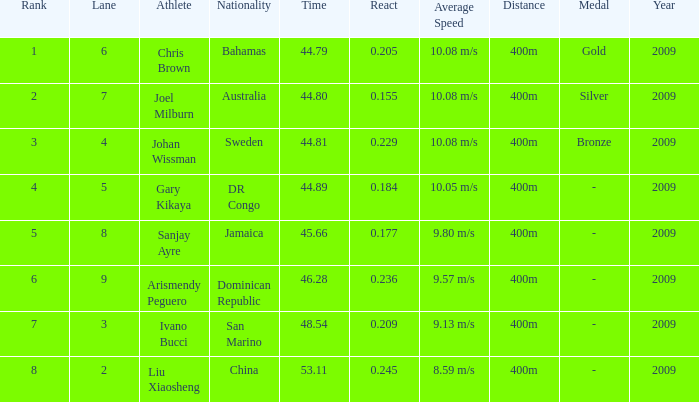How many total Time listings have a 0.209 React entry and a Rank that is greater than 7? 0.0. 